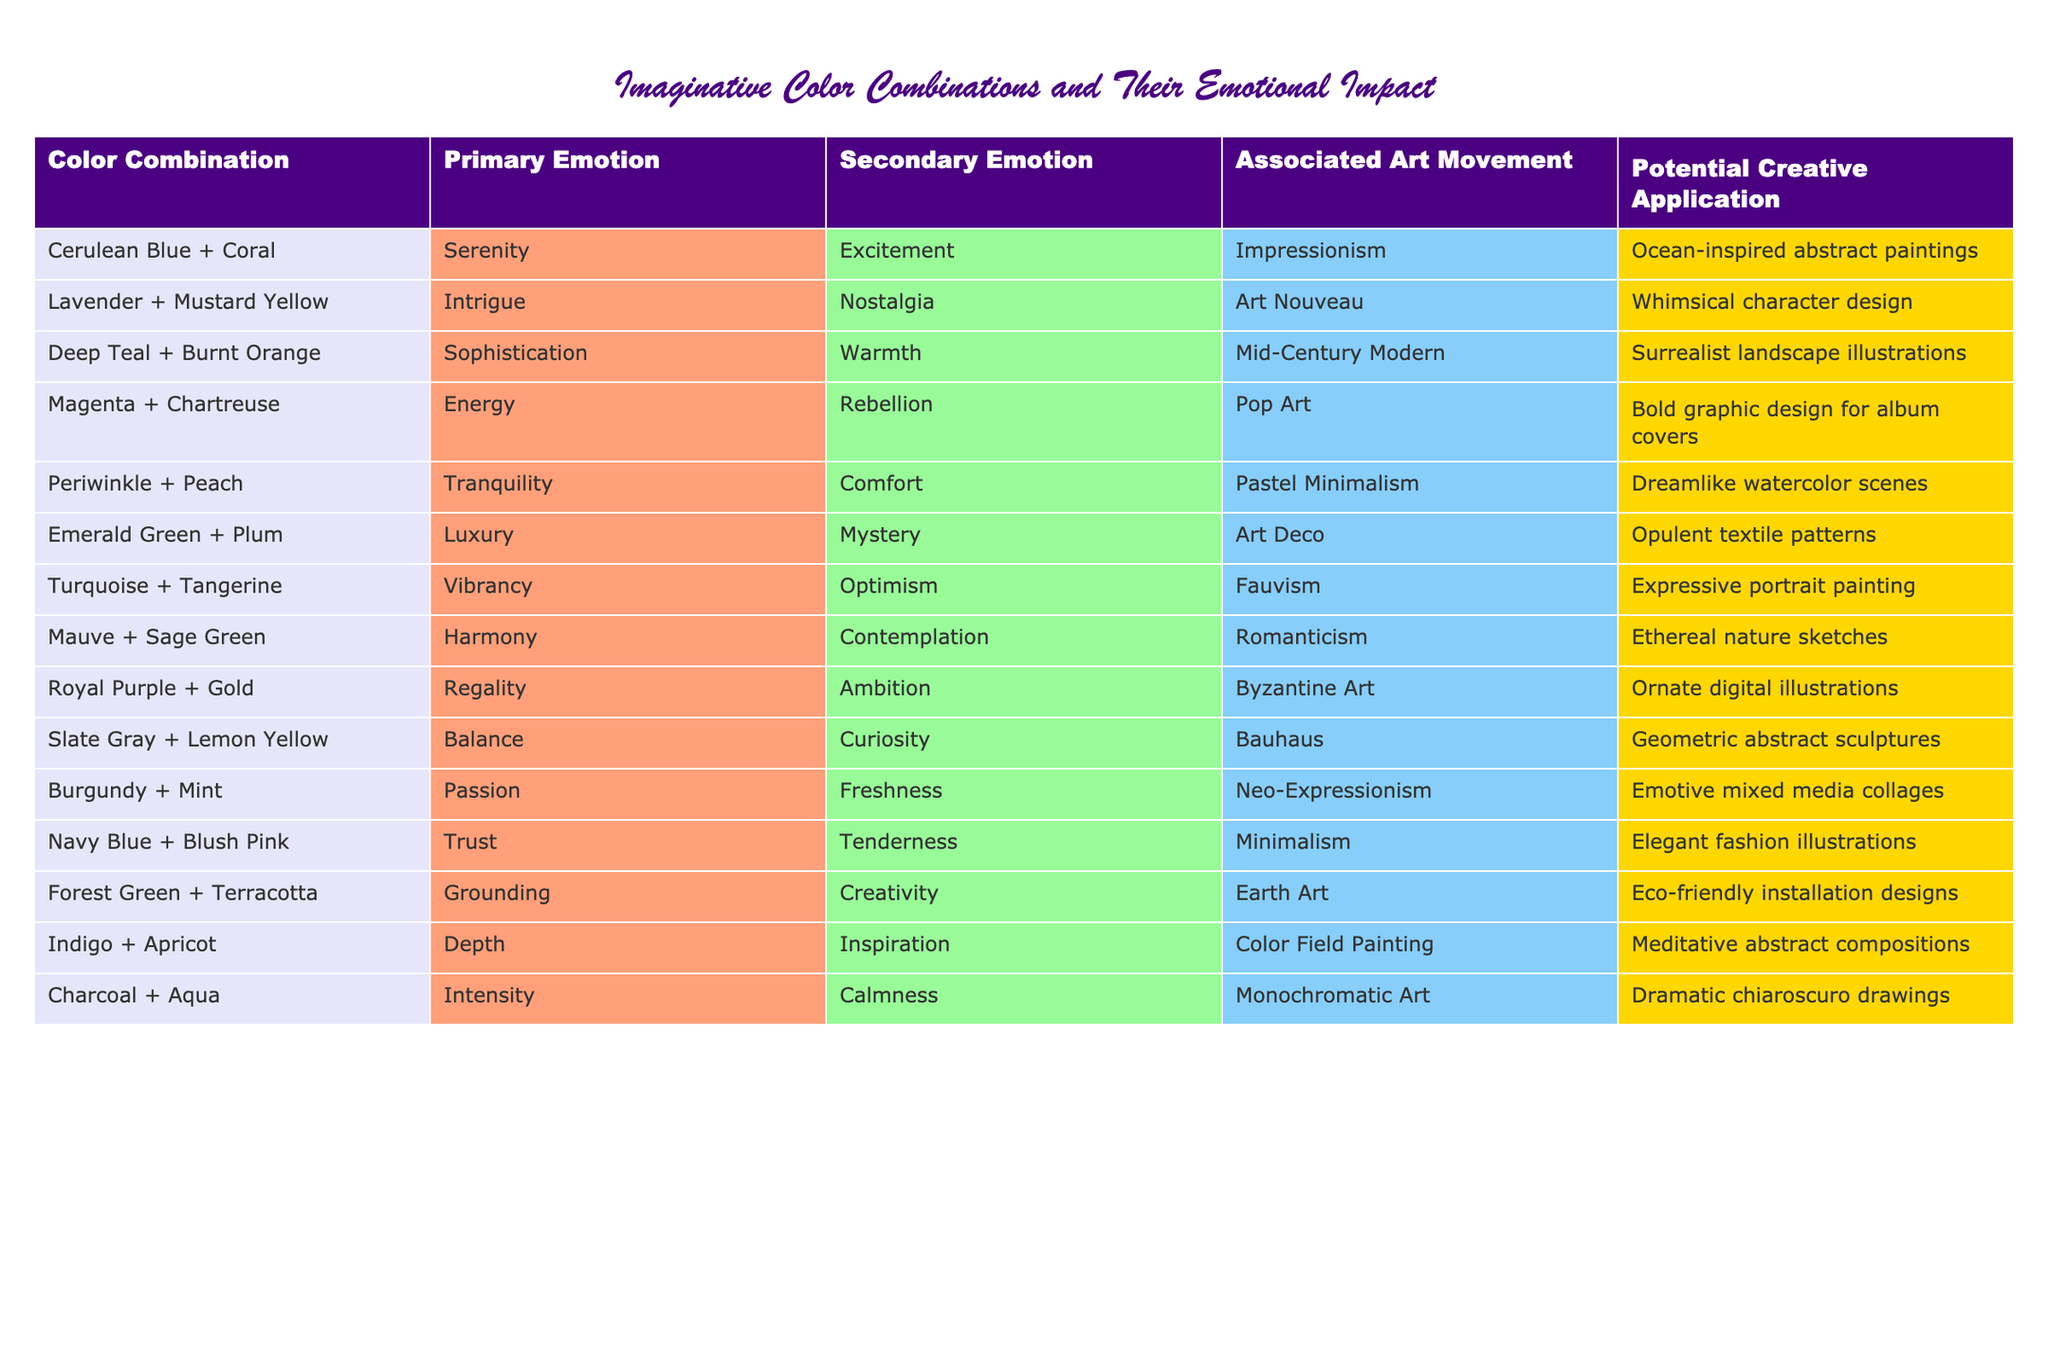What is the primary emotion associated with the color combination of Cerulean Blue and Coral? According to the table, the primary emotion listed for the combination of Cerulean Blue and Coral is Serenity.
Answer: Serenity Which color combination is linked to the art movement of Pop Art? The table shows that the color combination of Magenta and Chartreuse is associated with the Pop Art movement.
Answer: Magenta + Chartreuse Which color combination evokes the feelings of Grounding and Creativity? The table indicates that the color combination of Forest Green and Terracotta is connected to the emotions of Grounding and Creativity.
Answer: Forest Green + Terracotta Is Lavender + Mustard Yellow associated with the art movement of Impressionism? The table states that Lavender + Mustard Yellow is linked to the Art Nouveau movement, not Impressionism. Therefore, this fact is false.
Answer: No What color combination has the secondary emotion of Nostalgia? Looking at the table, Lavender + Mustard Yellow has the secondary emotion of Nostalgia.
Answer: Lavender + Mustard Yellow List the color combinations that give a sense of Tranquility. From the table, the combinations Periwinkle + Peach and Mauve + Sage Green are both associated with the primary emotion of Tranquility.
Answer: Periwinkle + Peach, Mauve + Sage Green Which color combinations have Luxury as a primary emotion? Referring to the table, only the combination of Emerald Green + Plum is linked to the primary emotion of Luxury.
Answer: Emerald Green + Plum Identify the art movement associated with the color combination of Burgundy + Mint. The table specifies that Burgundy + Mint is connected to the Neo-Expressionism art movement.
Answer: Neo-Expressionism What is the common art movement shared by both Deep Teal + Burnt Orange and Turquoise + Tangerine? The table reveals that Deep Teal + Burnt Orange is associated with Mid-Century Modern and Turquoise + Tangerine is linked to Fauvism. Therefore, there is no common art movement between them.
Answer: None Which color combination has the potential creative application of Eco-friendly installation designs? The table identifies Forest Green + Terracotta as the combination associated with Eco-friendly installation designs.
Answer: Forest Green + Terracotta 